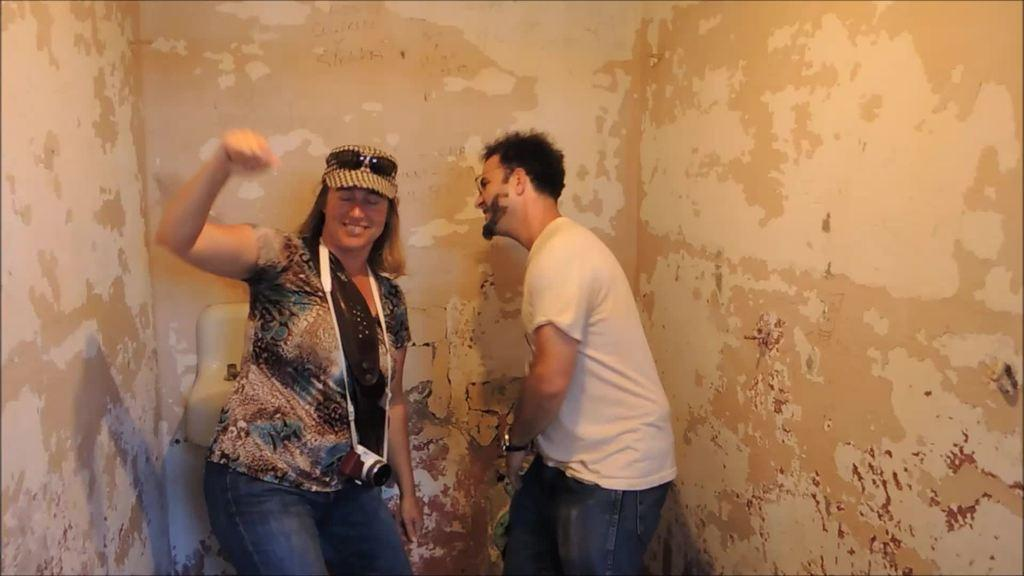How many people are in the image? There are two persons standing in the image. What object is visible in the image? A camera is visible in the image. What color is the wall in the background of the image? The wall in the background of the image has a cream color. What type of advice is the brain giving to the boy in the image? There is no brain or boy present in the image, so it is not possible to answer that question. 